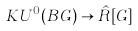Convert formula to latex. <formula><loc_0><loc_0><loc_500><loc_500>K U ^ { 0 } ( B G ) \rightarrow \hat { R } [ G ]</formula> 